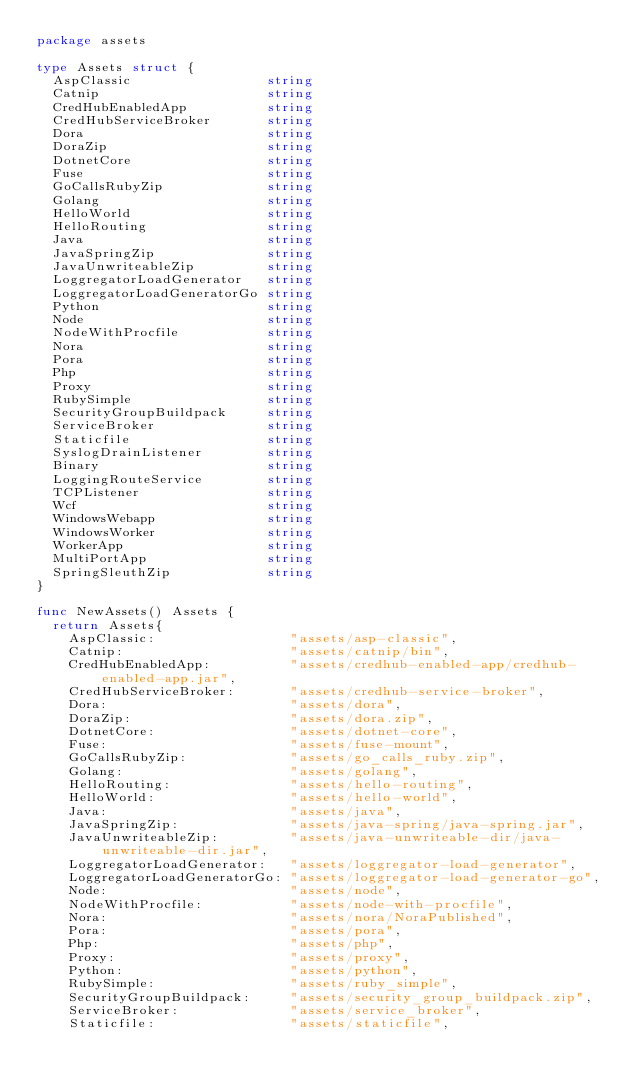<code> <loc_0><loc_0><loc_500><loc_500><_Go_>package assets

type Assets struct {
	AspClassic                 string
	Catnip                     string
	CredHubEnabledApp          string
	CredHubServiceBroker       string
	Dora                       string
	DoraZip                    string
	DotnetCore                 string
	Fuse                       string
	GoCallsRubyZip             string
	Golang                     string
	HelloWorld                 string
	HelloRouting               string
	Java                       string
	JavaSpringZip              string
	JavaUnwriteableZip         string
	LoggregatorLoadGenerator   string
	LoggregatorLoadGeneratorGo string
	Python                     string
	Node                       string
	NodeWithProcfile           string
	Nora                       string
	Pora                       string
	Php                        string
	Proxy                      string
	RubySimple                 string
	SecurityGroupBuildpack     string
	ServiceBroker              string
	Staticfile                 string
	SyslogDrainListener        string
	Binary                     string
	LoggingRouteService        string
	TCPListener                string
	Wcf                        string
	WindowsWebapp              string
	WindowsWorker              string
	WorkerApp                  string
	MultiPortApp               string
	SpringSleuthZip            string
}

func NewAssets() Assets {
	return Assets{
		AspClassic:                 "assets/asp-classic",
		Catnip:                     "assets/catnip/bin",
		CredHubEnabledApp:          "assets/credhub-enabled-app/credhub-enabled-app.jar",
		CredHubServiceBroker:       "assets/credhub-service-broker",
		Dora:                       "assets/dora",
		DoraZip:                    "assets/dora.zip",
		DotnetCore:                 "assets/dotnet-core",
		Fuse:                       "assets/fuse-mount",
		GoCallsRubyZip:             "assets/go_calls_ruby.zip",
		Golang:                     "assets/golang",
		HelloRouting:               "assets/hello-routing",
		HelloWorld:                 "assets/hello-world",
		Java:                       "assets/java",
		JavaSpringZip:              "assets/java-spring/java-spring.jar",
		JavaUnwriteableZip:         "assets/java-unwriteable-dir/java-unwriteable-dir.jar",
		LoggregatorLoadGenerator:   "assets/loggregator-load-generator",
		LoggregatorLoadGeneratorGo: "assets/loggregator-load-generator-go",
		Node:                       "assets/node",
		NodeWithProcfile:           "assets/node-with-procfile",
		Nora:                       "assets/nora/NoraPublished",
		Pora:                       "assets/pora",
		Php:                        "assets/php",
		Proxy:                      "assets/proxy",
		Python:                     "assets/python",
		RubySimple:                 "assets/ruby_simple",
		SecurityGroupBuildpack:     "assets/security_group_buildpack.zip",
		ServiceBroker:              "assets/service_broker",
		Staticfile:                 "assets/staticfile",</code> 